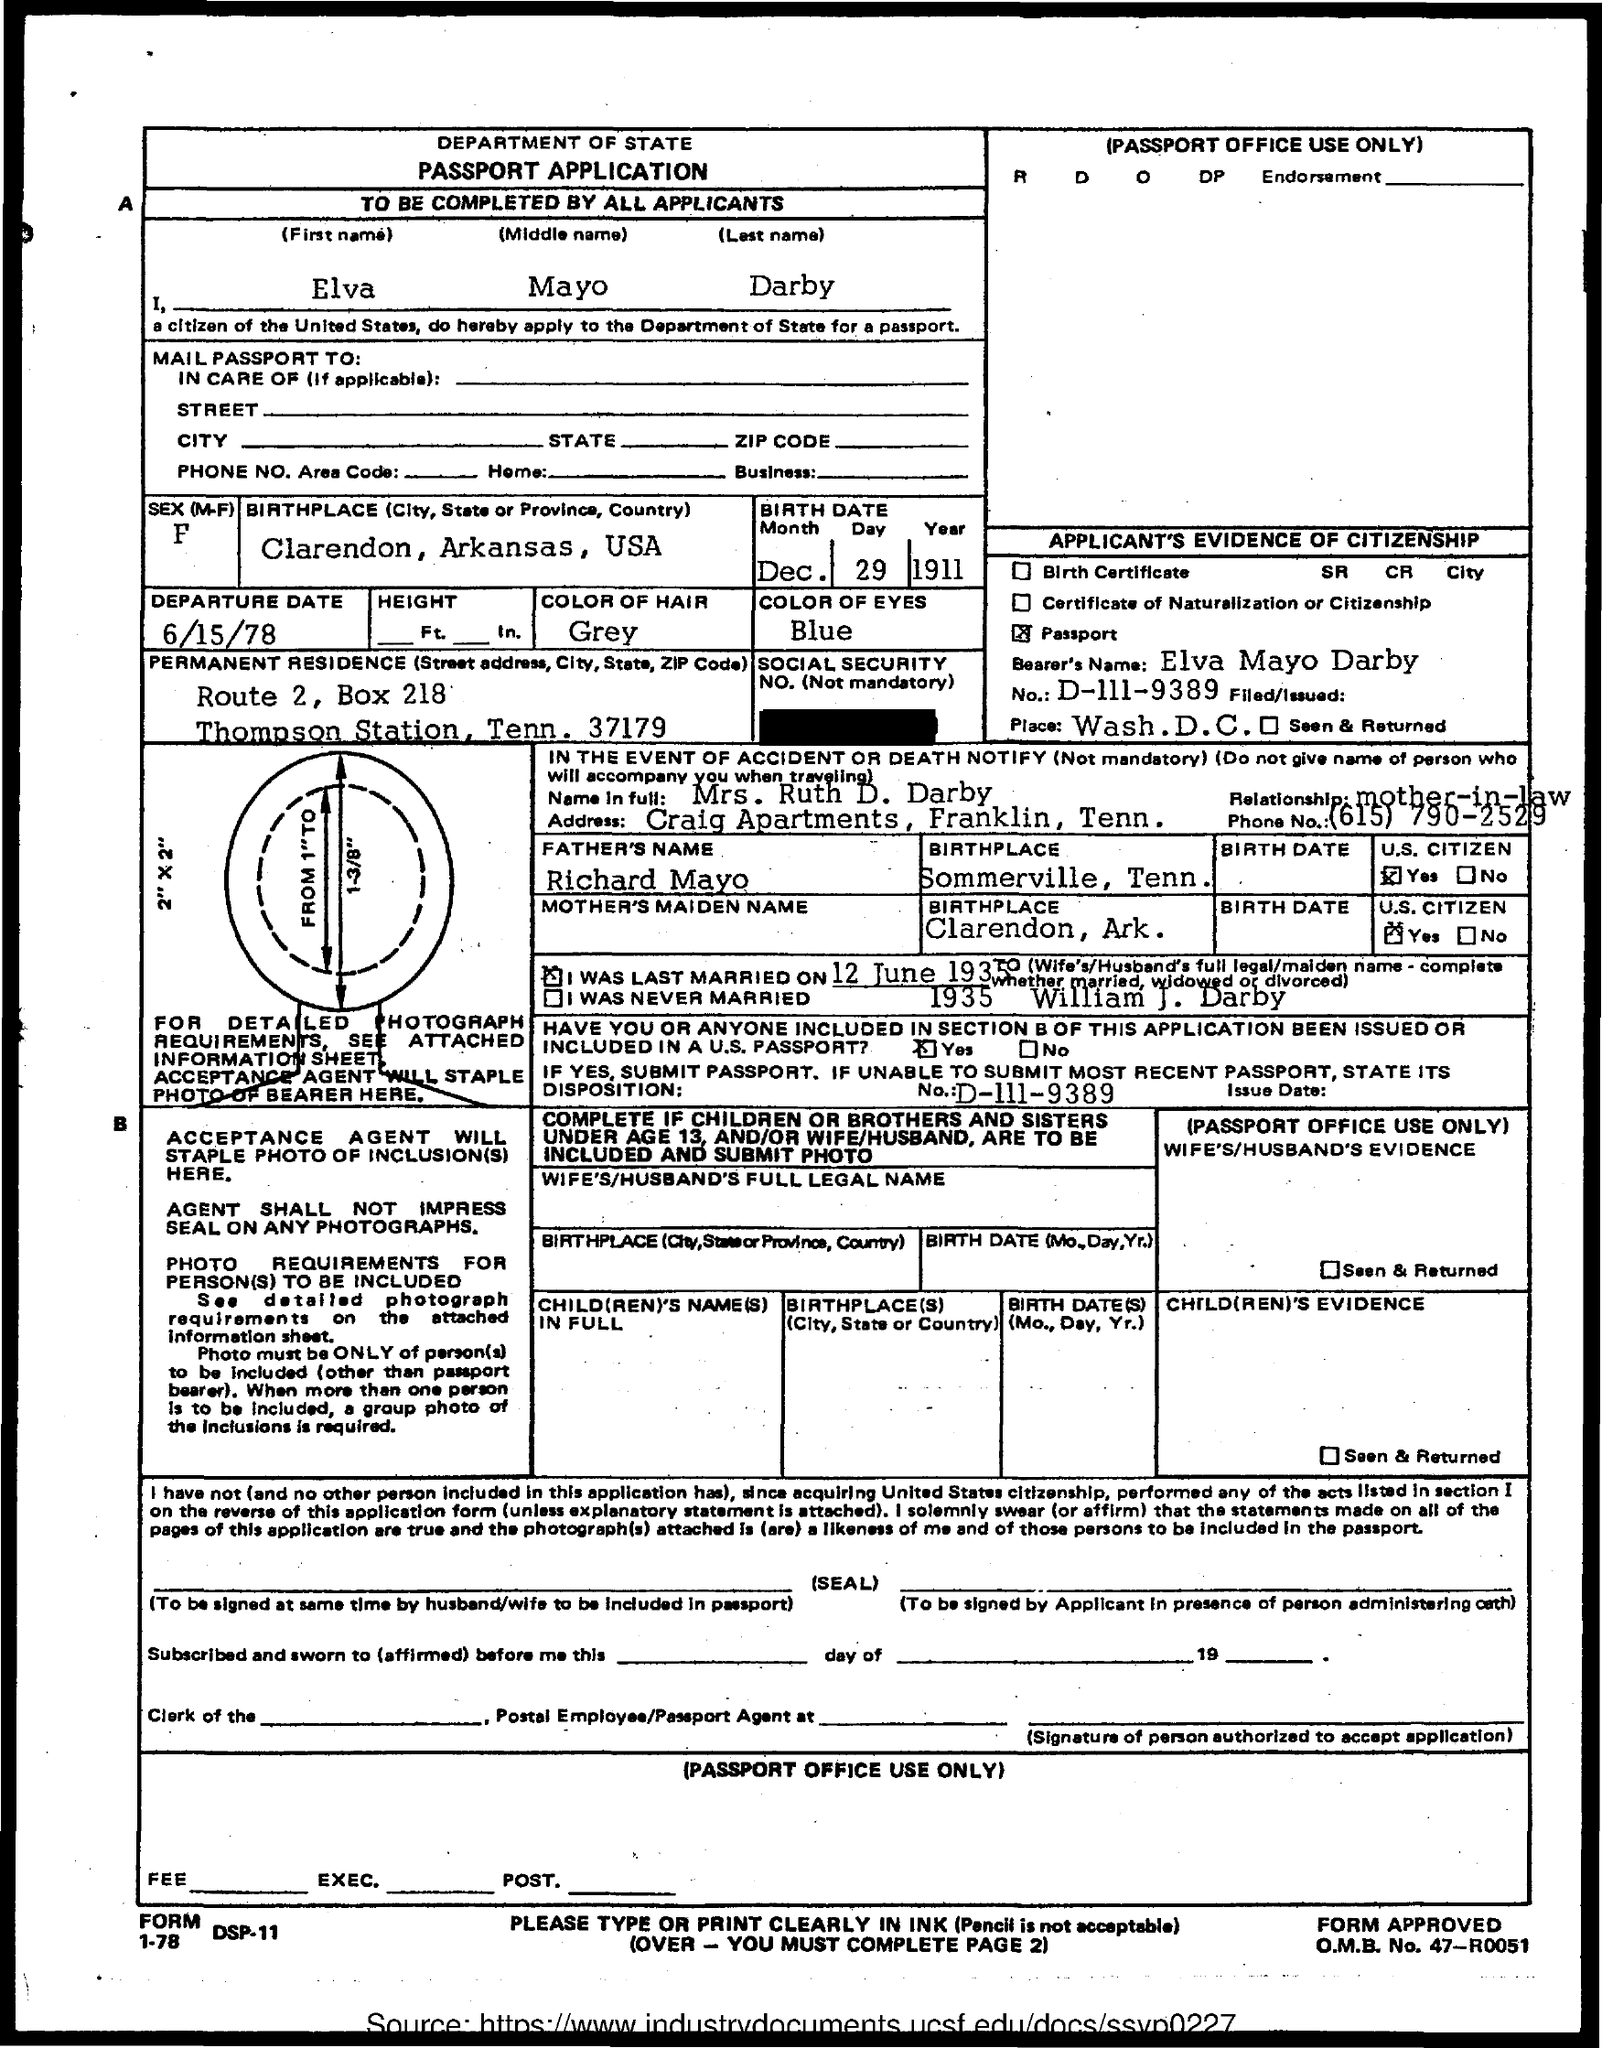What is the First Name of the applicant given here?
Ensure brevity in your answer.  Elva. Which is the Birthplace of Elva Mayo Darby?
Ensure brevity in your answer.  Clarendon, arkansas, usa. What is the Birth Date of Elva Mayo Darby?
Your answer should be compact. Dec. 29 1911. What is the Passport No. of Elva Mayo Darby?
Give a very brief answer. D-111-9389. What is the Departure date mentioned in the  passport application?
Provide a short and direct response. 6/15/78. Who is the Father of Elva Mayo Darby?
Provide a short and direct response. Richard Mayo. Which is the Birthplace of Richard Mayo?
Ensure brevity in your answer.  Sommerville, Tenn. 